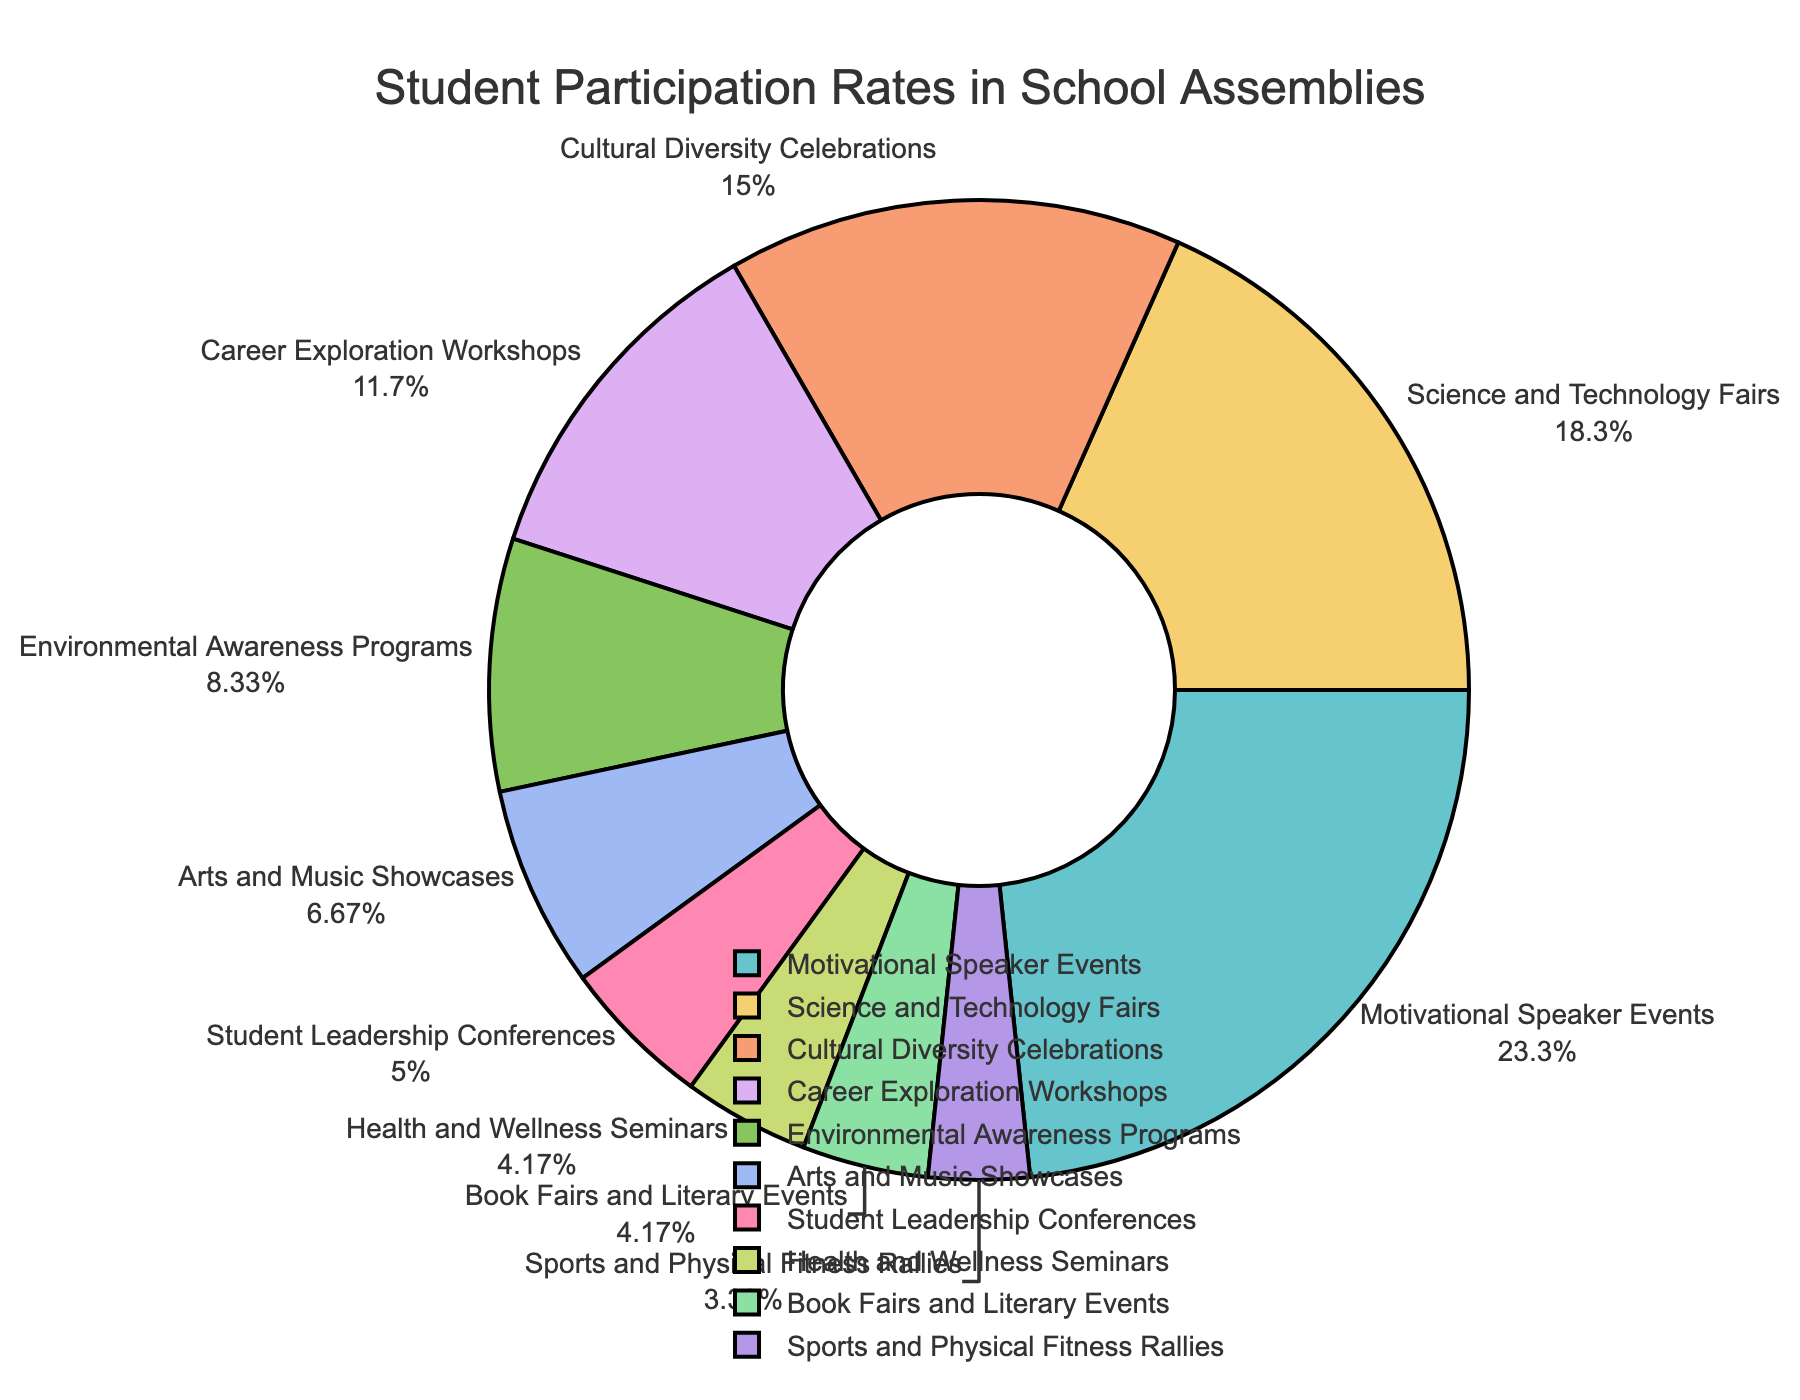What's the participation rate for Cultural Diversity Celebrations? To find the participation rate, locate the section labeled "Cultural Diversity Celebrations" in the pie chart. The participation rate is mentioned next to the label.
Answer: 18% Which assembly type has the lowest participation rate? Look for the smallest section of the pie chart and read its label. The label "Sports and Physical Fitness Rallies" corresponds to the smallest slice.
Answer: Sports and Physical Fitness Rallies What is the difference in participation rates between Science and Technology Fairs and Arts and Music Showcases? Find the participation rates for both: Science and Technology Fairs (22%) and Arts and Music Showcases (8%). Subtract the smaller value from the larger one: 22% - 8% = 14%.
Answer: 14% Which three assembly types have the highest participation rates, and what are their respective rates? Identify the three largest sections in the pie chart: "Motivational Speaker Events" (28%), "Science and Technology Fairs" (22%), and "Cultural Diversity Celebrations" (18%).
Answer: Motivational Speaker Events (28%), Science and Technology Fairs (22%), Cultural Diversity Celebrations (18%) What percentage of student participation is represented by Environmental Awareness Programs compared to Motivational Speaker Events? Find the participation rates for "Environmental Awareness Programs" (10%) and "Motivational Speaker Events" (28%). The comparison is 10%/28%. To express this as a percentage: (10/28) x 100 = 35.7%.
Answer: 35.7% What is the combined participation rate for Health and Wellness Seminars, Book Fairs and Literary Events, and Sports and Physical Fitness Rallies? Find the participation rates for each: Health and Wellness Seminars (5%), Book Fairs and Literary Events (5%), and Sports and Physical Fitness Rallies (4%). Sum them up: 5% + 5% + 4% = 14%.
Answer: 14% How does the participation for Career Exploration Workshops compare to that for Student Leadership Conferences? Find the participation rates for "Career Exploration Workshops" (14%) and "Student Leadership Conferences" (6%). Career Exploration Workshops have a higher rate: 14% > 6%
Answer: Career Exploration Workshops (14%) > Student Leadership Conferences (6%) What visual clues suggest that Motivational Speaker Events have the highest participation rate? The section for Motivational Speaker Events in the pie chart is the largest and occupies the largest proportion. This visual size directly indicates higher participation.
Answer: Largest section in the pie chart How much less is the participation in Arts and Music Showcases compared to Career Exploration Workshops? Find the participation rates for "Arts and Music Showcases" (8%) and "Career Exploration Workshops" (14%). Subtract the smaller value from the larger one: 14% - 8% = 6%.
Answer: 6% If we combine the participation rates of Science and Technology Fairs and Cultural Diversity Celebrations, what percentage of total student participation do they represent? Find the participation rates for "Science and Technology Fairs" (22%) and "Cultural Diversity Celebrations" (18%). Sum them up: 22% + 18% = 40%.
Answer: 40% 